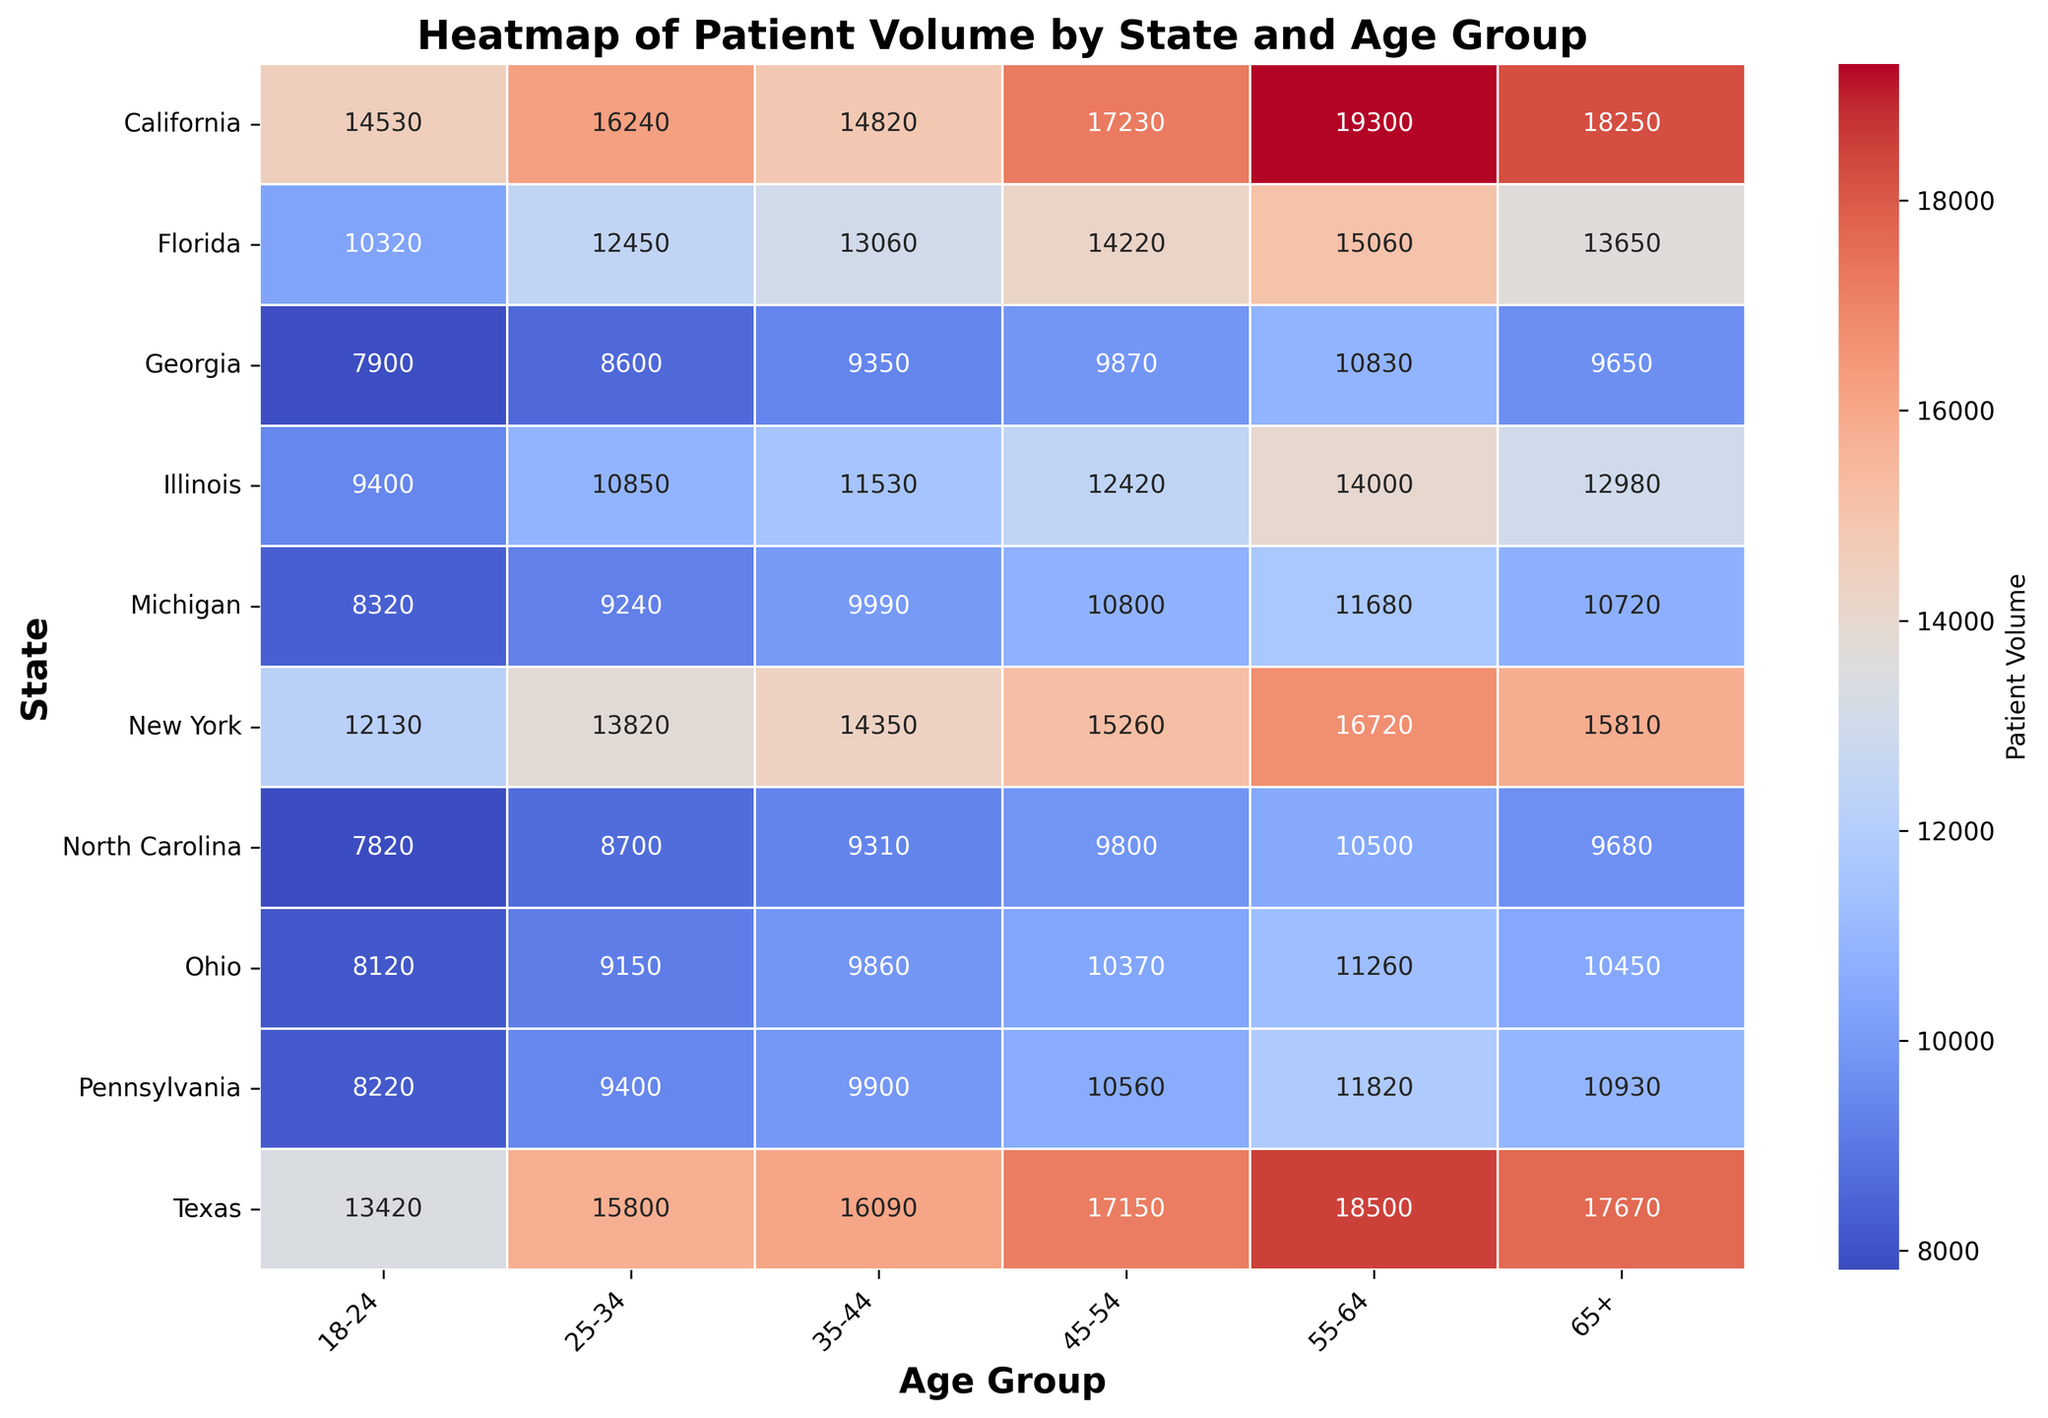Which state has the highest patient volume in the 55-64 age group? Look at the heatmap and identify the cell corresponding to the highest value in the column labelled "55-64". This cell should correspond to California.
Answer: California Which age group has the lowest patient volume in Pennsylvania? Check the values in the row for Pennsylvania. The lowest number among all age groups appears in the "18-24" column.
Answer: 18-24 Which state has the highest overall patient volume when summing across all age groups? Sum the patient volumes in each state across all age groups. The state with the highest sum will be California.
Answer: California How does the patient volume for the 35-44 age group in New York compare to that in Texas? Compare the values: for New York, it's 14350; for Texas, it's 16090. Texas has a higher patient volume than New York for this age group.
Answer: Texas On average, how does the patient volume for the 18-24 age group compare across all states? Sum all values in the "18-24" column and divide by the number of states (8). The values sum to 94560, and there are 8 states, so the average is 94560/8 = 11820.
Answer: 11820 Which age group in Illinois has the highest patient volume? Look at the values in the row for Illinois. The "55-64" group has the highest value, 14000.
Answer: 55-64 What is the difference in patient volume between the 25-34 and 65+ age groups in Ohio? Subtract the value in the "25-34" column from the value in the "65+" column for Ohio: 10450 - 9150 = 1300.
Answer: 1300 Which state shows the greatest variation in patient volume across different age groups? Examine the spread of patient volumes within each state's row. California shows the greatest variation due to having the highest range between its minimum and maximum values (14530 to 19300).
Answer: California What is the total patient volume for the 45-54 age group across all states? Sum the values in the "45-54" column: 17230 (CA) + 17150 (TX) + 14220 (FL) + 15260 (NY) + 12420 (IL) + 10560 (PA) + 10370 (OH) + 9870 (GA) + 9800 (NC) + 10800 (MI) = 137680.
Answer: 137680 